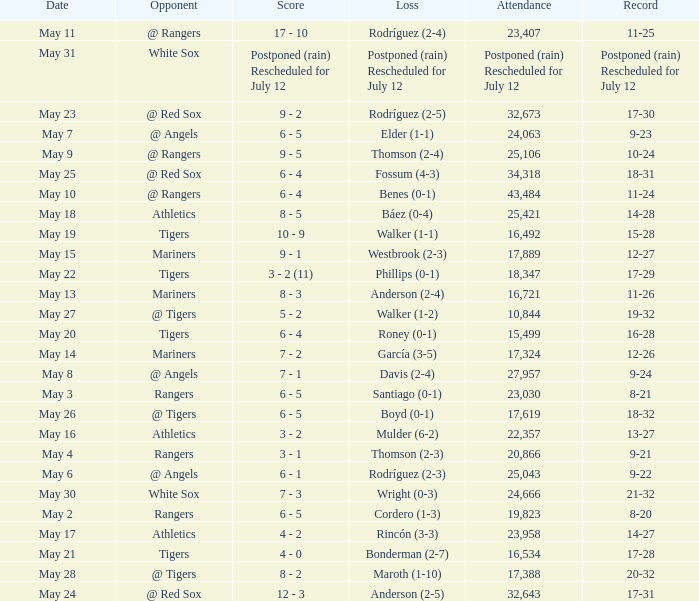What was the Indians record during the game that had 19,823 fans attending? 8-20. 